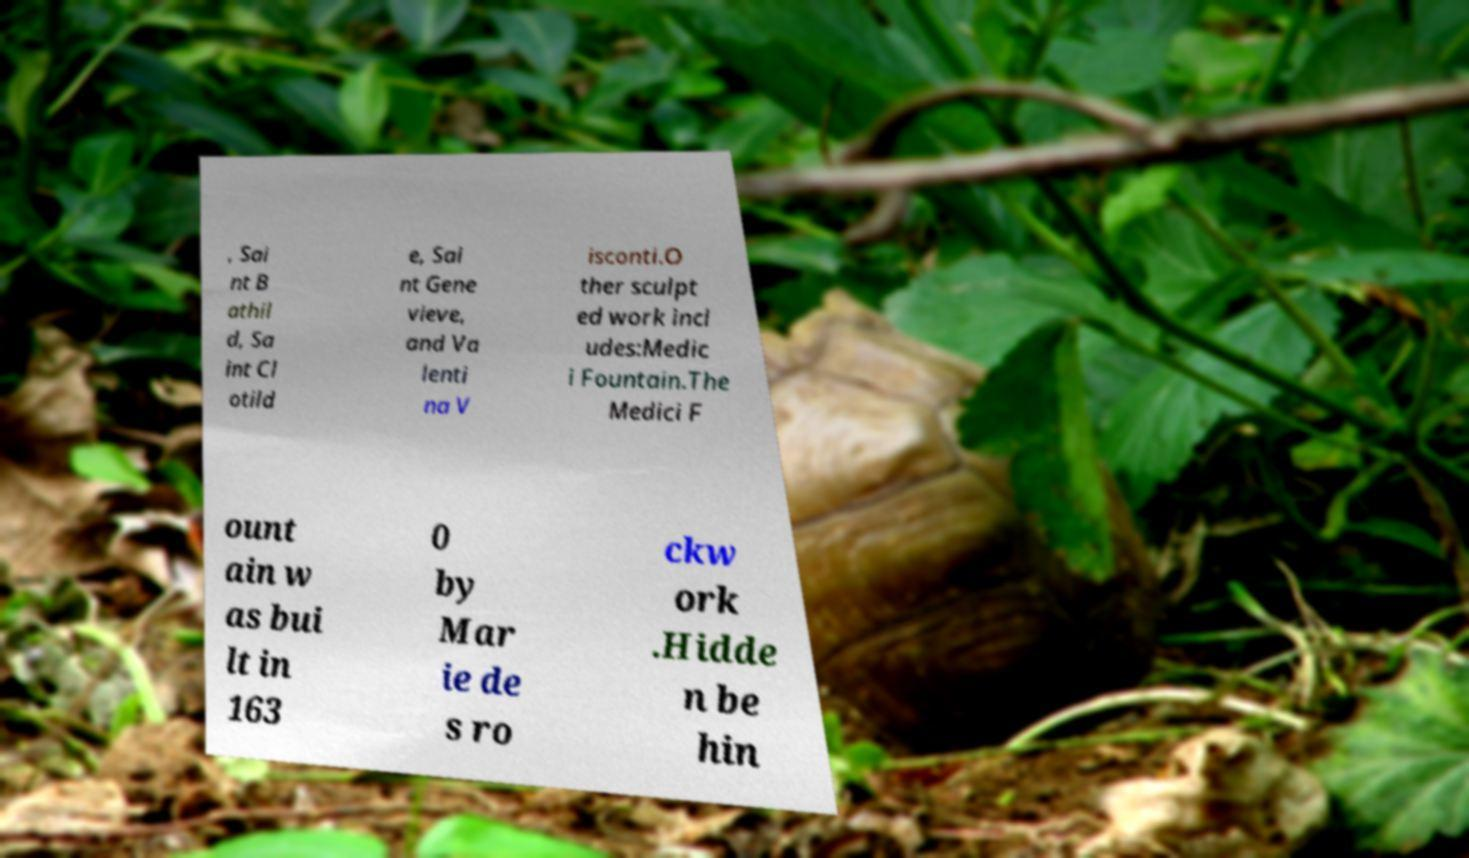For documentation purposes, I need the text within this image transcribed. Could you provide that? , Sai nt B athil d, Sa int Cl otild e, Sai nt Gene vieve, and Va lenti na V isconti.O ther sculpt ed work incl udes:Medic i Fountain.The Medici F ount ain w as bui lt in 163 0 by Mar ie de s ro ckw ork .Hidde n be hin 